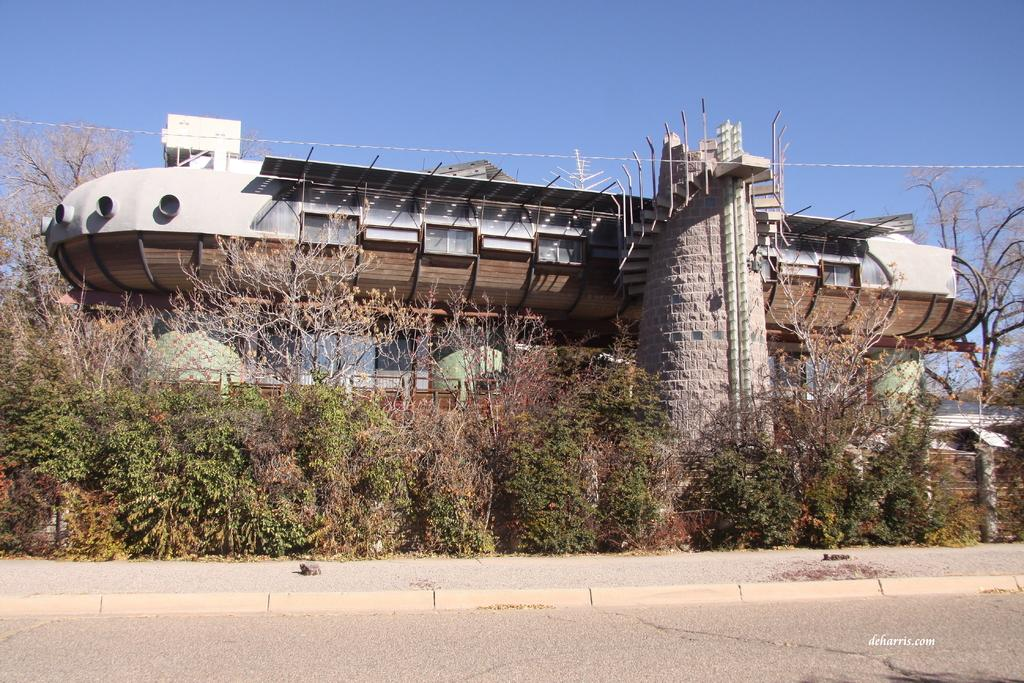What is the main subject in the middle of the image? There are trees in the middle of the image. What type of location is depicted in the image? The image depicts a construction site. What can be seen at the top of the image? The sky is visible at the top of the image. What type of shoe is the grandmother wearing at the construction site? There is no grandmother or shoe present in the image; it depicts a construction site with trees in the middle. 